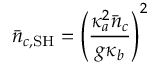Convert formula to latex. <formula><loc_0><loc_0><loc_500><loc_500>\bar { n } _ { c , S H } = \left ( \frac { \kappa _ { a } ^ { 2 } \bar { n } _ { c } } { g \kappa _ { b } } \right ) ^ { 2 }</formula> 